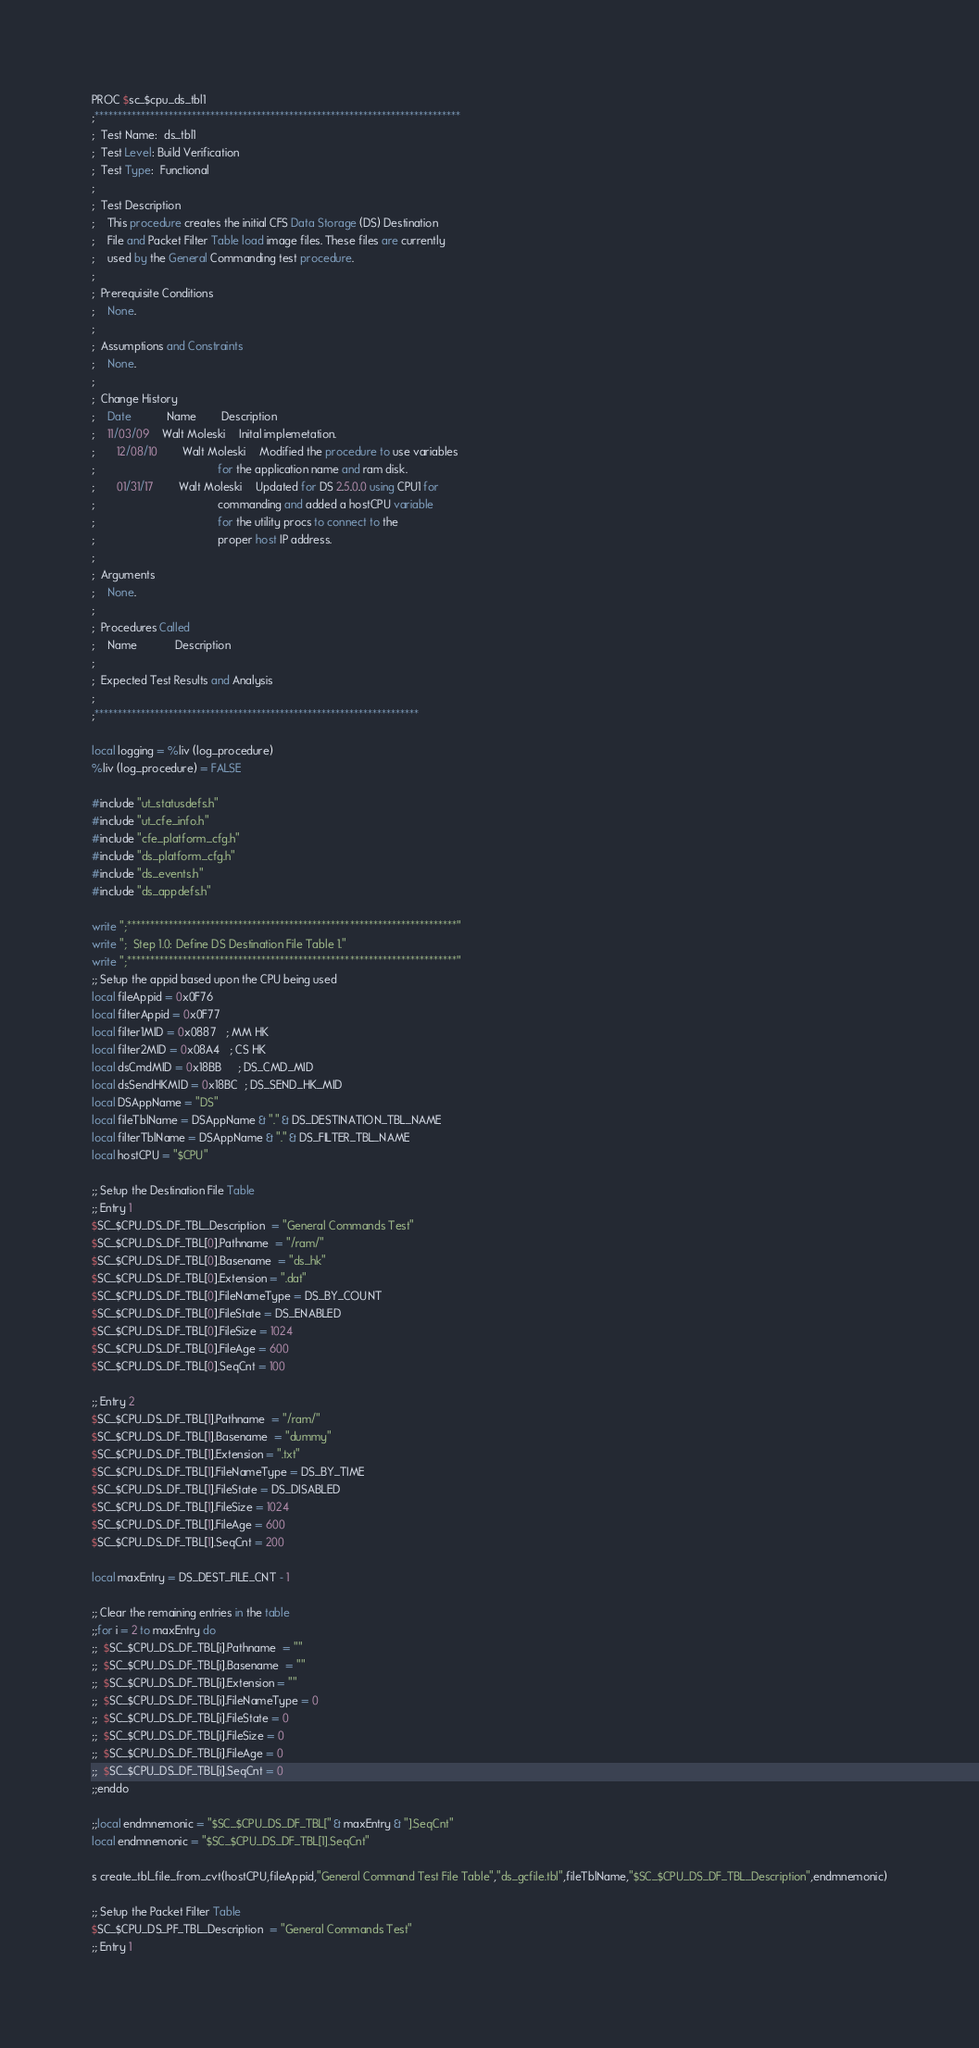<code> <loc_0><loc_0><loc_500><loc_500><_SQL_>PROC $sc_$cpu_ds_tbl1
;*******************************************************************************
;  Test Name:  ds_tbl1
;  Test Level: Build Verification
;  Test Type:  Functional
;
;  Test Description
;	This procedure creates the initial CFS Data Storage (DS) Destination
;	File and Packet Filter Table load image files. These files are currently
;	used by the General Commanding test procedure.
;	
;  Prerequisite Conditions
;	None.
;
;  Assumptions and Constraints
;	None.
;
;  Change History
;	Date		   Name		Description
;	11/03/09	Walt Moleski	Inital implemetation.
;       12/08/10        Walt Moleski    Modified the procedure to use variables
;                                       for the application name and ram disk.
;       01/31/17        Walt Moleski    Updated for DS 2.5.0.0 using CPU1 for
;                                       commanding and added a hostCPU variable
;                                       for the utility procs to connect to the
;                                       proper host IP address.
;
;  Arguments
;	None.
;
;  Procedures Called
;	Name			Description
;
;  Expected Test Results and Analysis
;
;**********************************************************************

local logging = %liv (log_procedure)
%liv (log_procedure) = FALSE

#include "ut_statusdefs.h"
#include "ut_cfe_info.h"
#include "cfe_platform_cfg.h"
#include "ds_platform_cfg.h"
#include "ds_events.h"
#include "ds_appdefs.h"

write ";***********************************************************************"
write ";  Step 1.0: Define DS Destination File Table 1."
write ";***********************************************************************"
;; Setup the appid based upon the CPU being used
local fileAppid = 0x0F76
local filterAppid = 0x0F77
local filter1MID = 0x0887   ; MM HK
local filter2MID = 0x08A4   ; CS HK
local dsCmdMID = 0x18BB     ; DS_CMD_MID
local dsSendHKMID = 0x18BC  ; DS_SEND_HK_MID
local DSAppName = "DS"  
local fileTblName = DSAppName & "." & DS_DESTINATION_TBL_NAME
local filterTblName = DSAppName & "." & DS_FILTER_TBL_NAME
local hostCPU = "$CPU"

;; Setup the Destination File Table
;; Entry 1
$SC_$CPU_DS_DF_TBL_Description  = "General Commands Test"
$SC_$CPU_DS_DF_TBL[0].Pathname  = "/ram/"
$SC_$CPU_DS_DF_TBL[0].Basename  = "ds_hk"
$SC_$CPU_DS_DF_TBL[0].Extension = ".dat"
$SC_$CPU_DS_DF_TBL[0].FileNameType = DS_BY_COUNT
$SC_$CPU_DS_DF_TBL[0].FileState = DS_ENABLED
$SC_$CPU_DS_DF_TBL[0].FileSize = 1024
$SC_$CPU_DS_DF_TBL[0].FileAge = 600
$SC_$CPU_DS_DF_TBL[0].SeqCnt = 100

;; Entry 2
$SC_$CPU_DS_DF_TBL[1].Pathname  = "/ram/"
$SC_$CPU_DS_DF_TBL[1].Basename  = "dummy"
$SC_$CPU_DS_DF_TBL[1].Extension = ".txt"
$SC_$CPU_DS_DF_TBL[1].FileNameType = DS_BY_TIME
$SC_$CPU_DS_DF_TBL[1].FileState = DS_DISABLED
$SC_$CPU_DS_DF_TBL[1].FileSize = 1024
$SC_$CPU_DS_DF_TBL[1].FileAge = 600
$SC_$CPU_DS_DF_TBL[1].SeqCnt = 200

local maxEntry = DS_DEST_FILE_CNT - 1

;; Clear the remaining entries in the table
;;for i = 2 to maxEntry do
;;  $SC_$CPU_DS_DF_TBL[i].Pathname  = ""
;;  $SC_$CPU_DS_DF_TBL[i].Basename  = ""
;;  $SC_$CPU_DS_DF_TBL[i].Extension = ""
;;  $SC_$CPU_DS_DF_TBL[i].FileNameType = 0
;;  $SC_$CPU_DS_DF_TBL[i].FileState = 0
;;  $SC_$CPU_DS_DF_TBL[i].FileSize = 0
;;  $SC_$CPU_DS_DF_TBL[i].FileAge = 0
;;  $SC_$CPU_DS_DF_TBL[i].SeqCnt = 0
;;enddo

;;local endmnemonic = "$SC_$CPU_DS_DF_TBL[" & maxEntry & "].SeqCnt"
local endmnemonic = "$SC_$CPU_DS_DF_TBL[1].SeqCnt"

s create_tbl_file_from_cvt(hostCPU,fileAppid,"General Command Test File Table","ds_gcfile.tbl",fileTblName,"$SC_$CPU_DS_DF_TBL_Description",endmnemonic)

;; Setup the Packet Filter Table
$SC_$CPU_DS_PF_TBL_Description  = "General Commands Test"
;; Entry 1</code> 